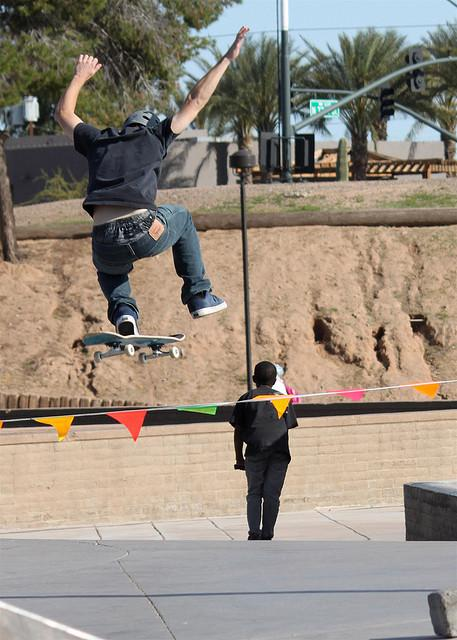In what setting is the skater skating? skate park 